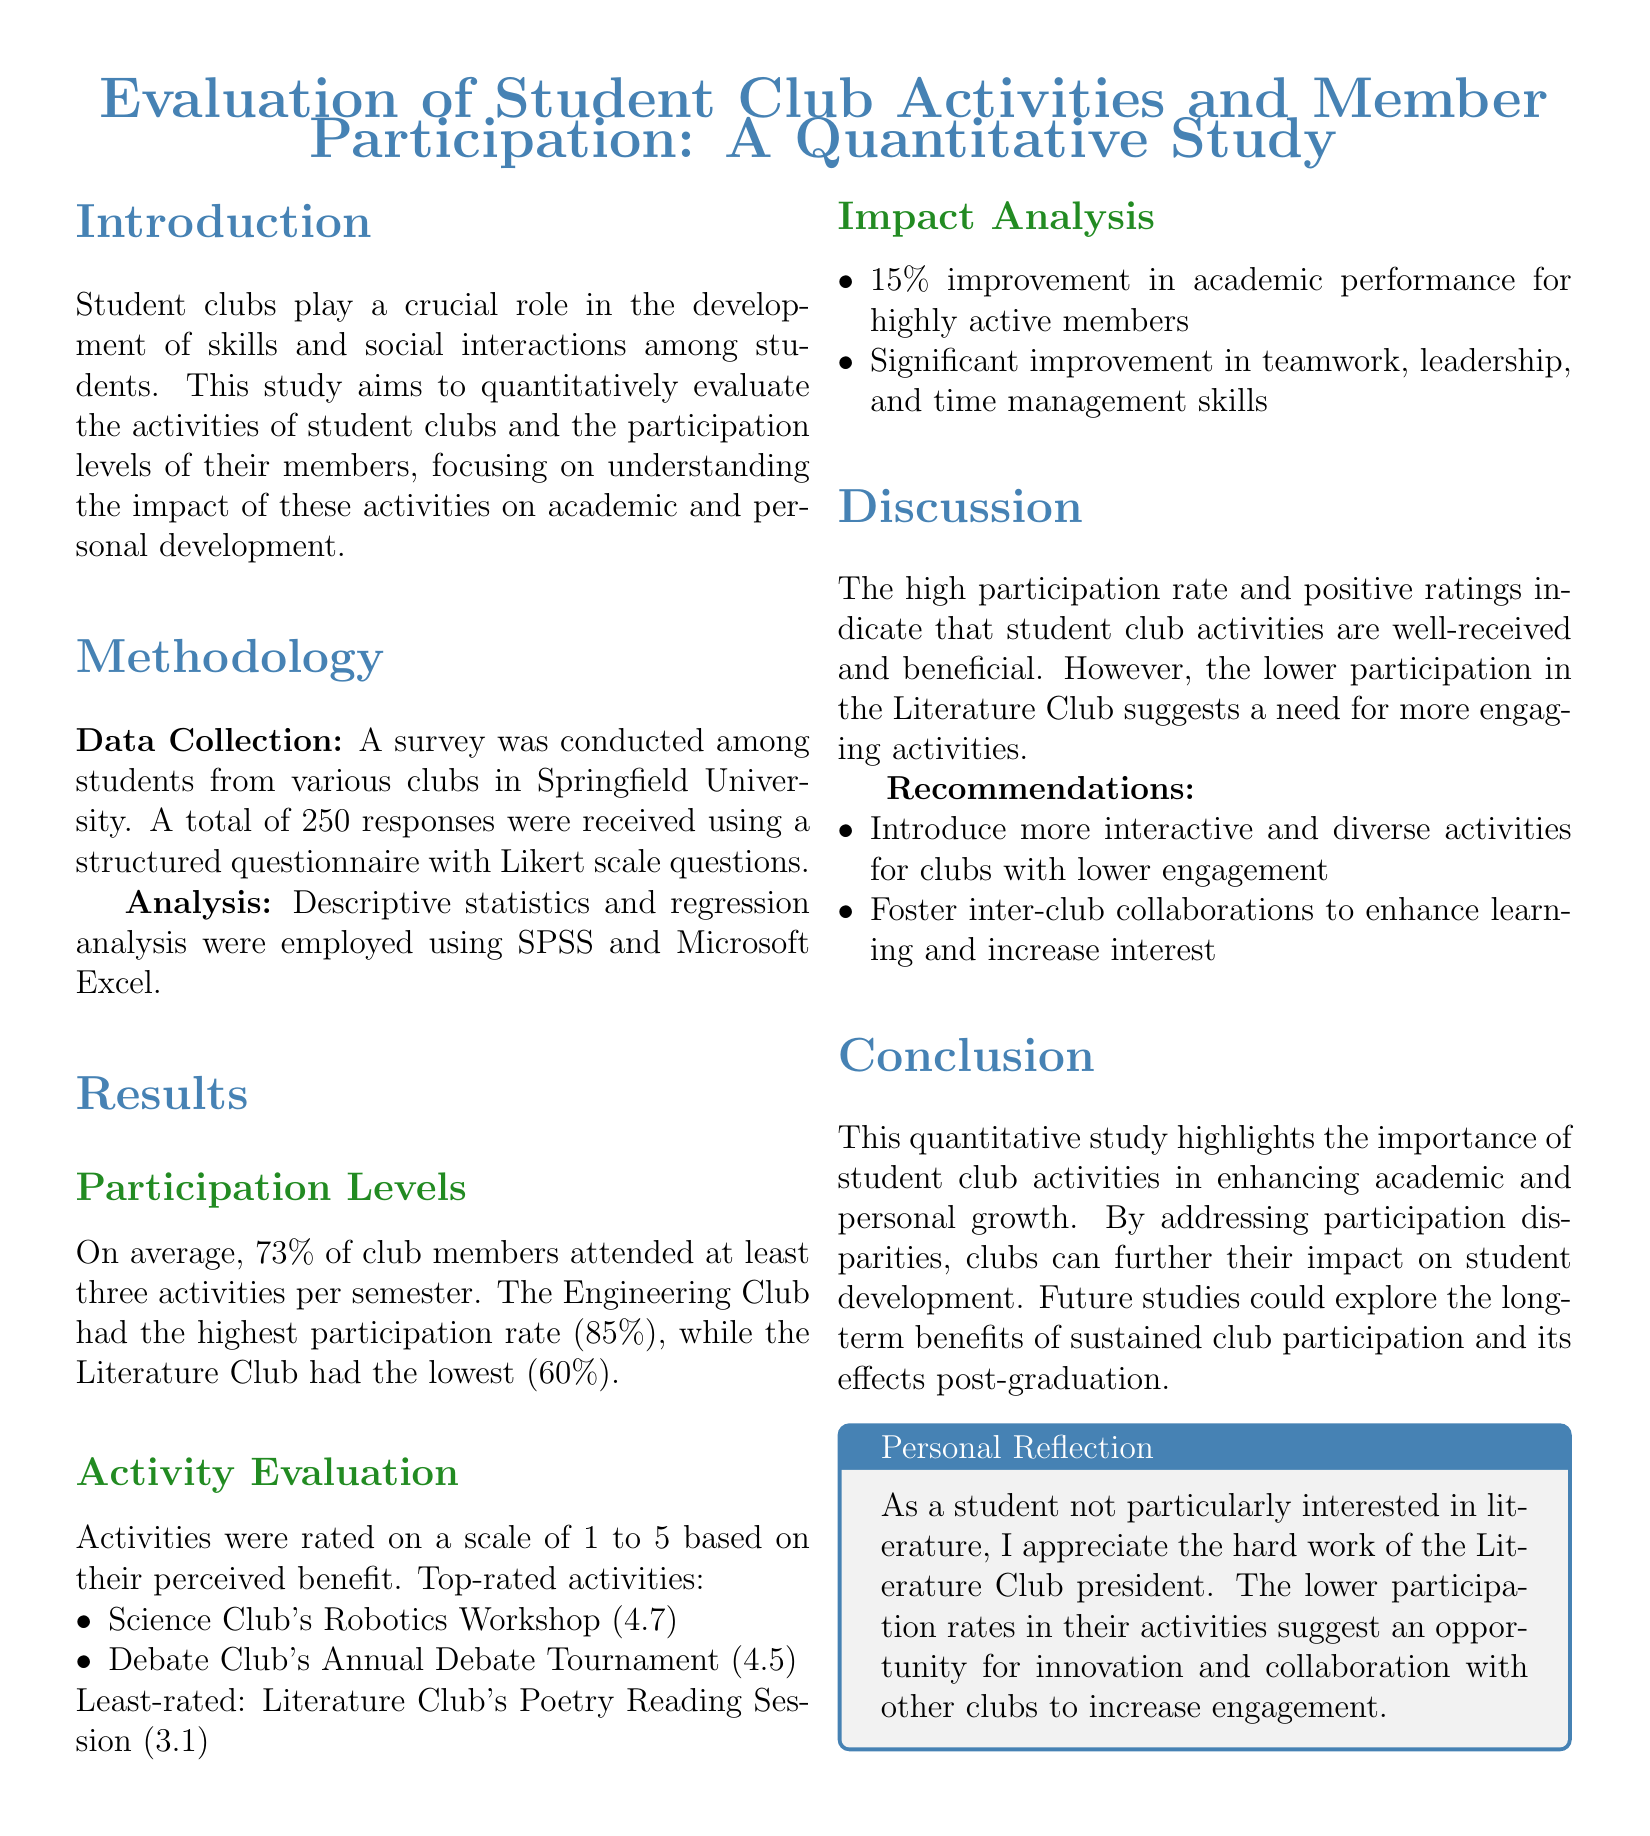What is the average participation rate of club members? The average participation rate is calculated from the survey results, showing that 73% of club members attended at least three activities per semester.
Answer: 73% Which club had the highest participation rate? The document states that the Engineering Club had the highest participation rate of 85%.
Answer: Engineering Club What was the rating of the Science Club's Robotics Workshop? The Robotics Workshop is rated 4.7 on a scale of 1 to 5 based on perceived benefit.
Answer: 4.7 What improvement percentage was observed in academic performance for highly active members? The report indicates a 15% improvement in academic performance for highly active members.
Answer: 15% What does the report suggest for clubs with lower engagement? The document recommends introducing more interactive and diverse activities for clubs with lower engagement.
Answer: More interactive and diverse activities What was the least-rated activity mentioned in the results? The least-rated activity was the Literature Club's Poetry Reading Session, which received a rating of 3.1.
Answer: Poetry Reading Session What is the primary goal of this study? The aim of the study is to quantitatively evaluate student club activities and member participation, focusing on their impact on personal and academic development.
Answer: Evaluate student club activities What analytical tools were used in the study? The tools used for analysis included SPSS and Microsoft Excel, as mentioned in the methodology section.
Answer: SPSS and Microsoft Excel What kind of skills showed significant improvement due to club activities? The skills that showed significant improvement included teamwork, leadership, and time management.
Answer: Teamwork, leadership, and time management 